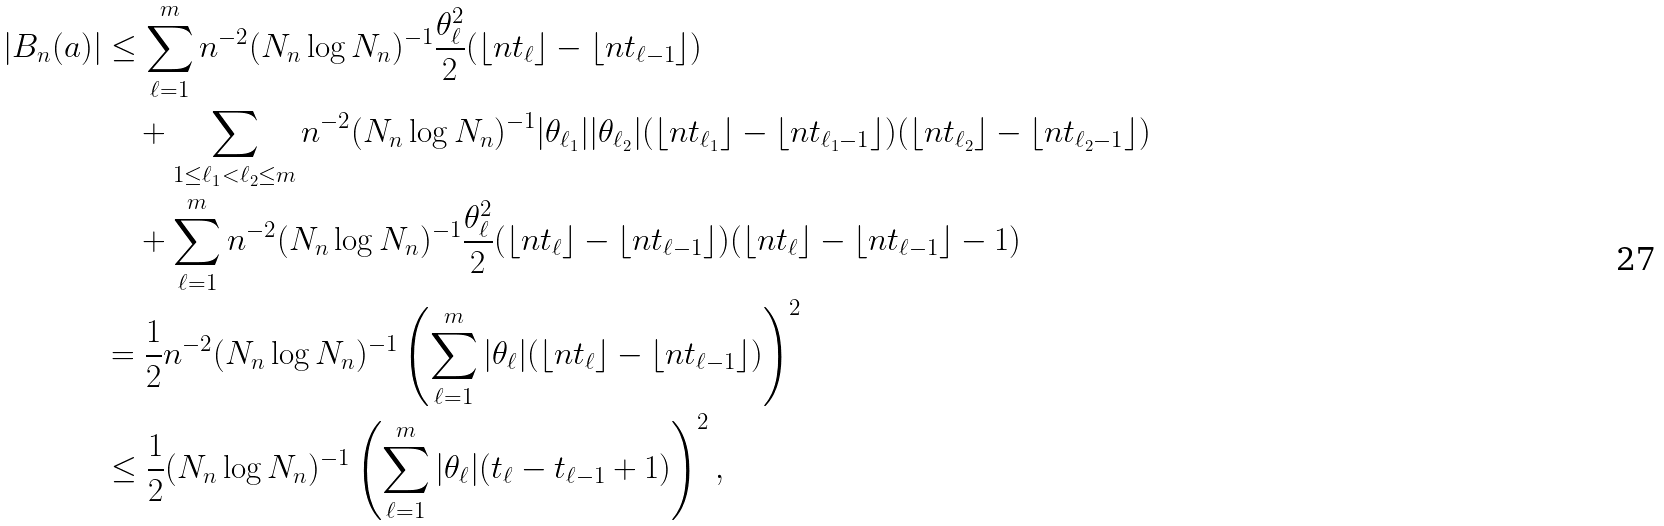Convert formula to latex. <formula><loc_0><loc_0><loc_500><loc_500>| B _ { n } ( a ) | & \leq \sum _ { \ell = 1 } ^ { m } n ^ { - 2 } { ( N _ { n } \log N _ { n } ) ^ { - 1 } } \frac { \theta _ { \ell } ^ { 2 } } { 2 } ( \lfloor n t _ { \ell } \rfloor - \lfloor n t _ { \ell - 1 } \rfloor ) \\ & \quad + \sum _ { 1 \leq \ell _ { 1 } < \ell _ { 2 } \leq m } n ^ { - 2 } { ( N _ { n } \log N _ { n } ) ^ { - 1 } } | \theta _ { \ell _ { 1 } } | | \theta _ { \ell _ { 2 } } | ( \lfloor n t _ { \ell _ { 1 } } \rfloor - \lfloor n t _ { \ell _ { 1 } - 1 } \rfloor ) ( \lfloor n t _ { \ell _ { 2 } } \rfloor - \lfloor n t _ { \ell _ { 2 } - 1 } \rfloor ) \\ & \quad + \sum _ { \ell = 1 } ^ { m } n ^ { - 2 } { ( N _ { n } \log N _ { n } ) ^ { - 1 } } \frac { \theta _ { \ell } ^ { 2 } } { 2 } ( \lfloor n t _ { \ell } \rfloor - \lfloor n t _ { \ell - 1 } \rfloor ) ( \lfloor n t _ { \ell } \rfloor - \lfloor n t _ { \ell - 1 } \rfloor - 1 ) \\ & = \frac { 1 } { 2 } n ^ { - 2 } { ( N _ { n } \log N _ { n } ) ^ { - 1 } } \left ( \sum _ { \ell = 1 } ^ { m } | \theta _ { \ell } | ( \lfloor n t _ { \ell } \rfloor - \lfloor n t _ { \ell - 1 } \rfloor ) \right ) ^ { 2 } \\ & \leq \frac { 1 } { 2 } { ( N _ { n } \log N _ { n } ) ^ { - 1 } } \left ( \sum _ { \ell = 1 } ^ { m } | \theta _ { \ell } | ( t _ { \ell } - t _ { \ell - 1 } + 1 ) \right ) ^ { 2 } ,</formula> 